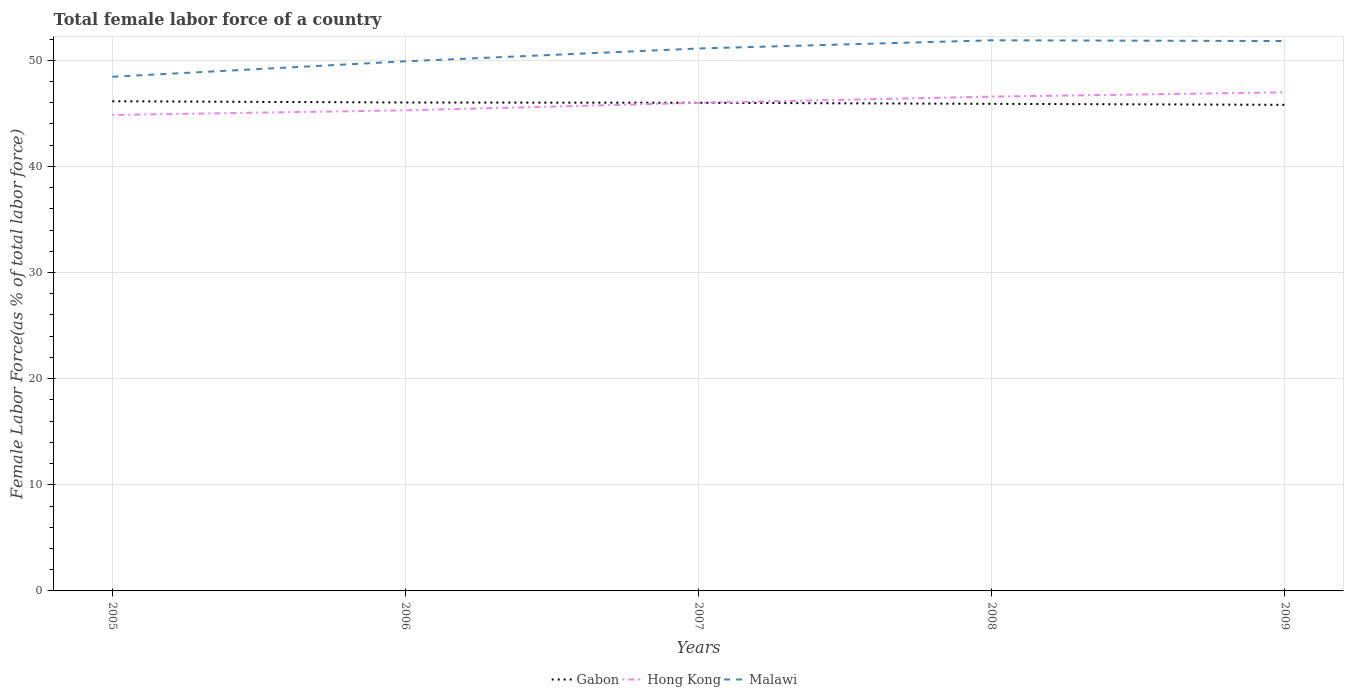Does the line corresponding to Gabon intersect with the line corresponding to Malawi?
Your answer should be very brief. No. Across all years, what is the maximum percentage of female labor force in Malawi?
Provide a short and direct response. 48.44. In which year was the percentage of female labor force in Hong Kong maximum?
Your answer should be very brief. 2005. What is the total percentage of female labor force in Malawi in the graph?
Keep it short and to the point. 0.07. What is the difference between the highest and the second highest percentage of female labor force in Gabon?
Your response must be concise. 0.34. What is the difference between the highest and the lowest percentage of female labor force in Gabon?
Your response must be concise. 3. Is the percentage of female labor force in Hong Kong strictly greater than the percentage of female labor force in Gabon over the years?
Give a very brief answer. No. How many lines are there?
Offer a very short reply. 3. Are the values on the major ticks of Y-axis written in scientific E-notation?
Make the answer very short. No. Does the graph contain any zero values?
Provide a succinct answer. No. Does the graph contain grids?
Provide a short and direct response. Yes. How are the legend labels stacked?
Your answer should be compact. Horizontal. What is the title of the graph?
Ensure brevity in your answer.  Total female labor force of a country. Does "Hungary" appear as one of the legend labels in the graph?
Ensure brevity in your answer.  No. What is the label or title of the Y-axis?
Ensure brevity in your answer.  Female Labor Force(as % of total labor force). What is the Female Labor Force(as % of total labor force) in Gabon in 2005?
Offer a terse response. 46.13. What is the Female Labor Force(as % of total labor force) in Hong Kong in 2005?
Provide a succinct answer. 44.84. What is the Female Labor Force(as % of total labor force) in Malawi in 2005?
Your response must be concise. 48.44. What is the Female Labor Force(as % of total labor force) in Gabon in 2006?
Offer a very short reply. 46.02. What is the Female Labor Force(as % of total labor force) of Hong Kong in 2006?
Keep it short and to the point. 45.28. What is the Female Labor Force(as % of total labor force) in Malawi in 2006?
Provide a succinct answer. 49.9. What is the Female Labor Force(as % of total labor force) of Gabon in 2007?
Keep it short and to the point. 45.99. What is the Female Labor Force(as % of total labor force) in Hong Kong in 2007?
Your response must be concise. 45.99. What is the Female Labor Force(as % of total labor force) in Malawi in 2007?
Offer a very short reply. 51.11. What is the Female Labor Force(as % of total labor force) of Gabon in 2008?
Offer a very short reply. 45.89. What is the Female Labor Force(as % of total labor force) in Hong Kong in 2008?
Ensure brevity in your answer.  46.57. What is the Female Labor Force(as % of total labor force) in Malawi in 2008?
Keep it short and to the point. 51.88. What is the Female Labor Force(as % of total labor force) in Gabon in 2009?
Your answer should be compact. 45.8. What is the Female Labor Force(as % of total labor force) in Hong Kong in 2009?
Offer a very short reply. 46.98. What is the Female Labor Force(as % of total labor force) of Malawi in 2009?
Keep it short and to the point. 51.81. Across all years, what is the maximum Female Labor Force(as % of total labor force) of Gabon?
Offer a very short reply. 46.13. Across all years, what is the maximum Female Labor Force(as % of total labor force) in Hong Kong?
Ensure brevity in your answer.  46.98. Across all years, what is the maximum Female Labor Force(as % of total labor force) of Malawi?
Your response must be concise. 51.88. Across all years, what is the minimum Female Labor Force(as % of total labor force) of Gabon?
Provide a short and direct response. 45.8. Across all years, what is the minimum Female Labor Force(as % of total labor force) in Hong Kong?
Provide a short and direct response. 44.84. Across all years, what is the minimum Female Labor Force(as % of total labor force) of Malawi?
Keep it short and to the point. 48.44. What is the total Female Labor Force(as % of total labor force) in Gabon in the graph?
Your response must be concise. 229.84. What is the total Female Labor Force(as % of total labor force) in Hong Kong in the graph?
Offer a very short reply. 229.65. What is the total Female Labor Force(as % of total labor force) of Malawi in the graph?
Ensure brevity in your answer.  253.13. What is the difference between the Female Labor Force(as % of total labor force) of Gabon in 2005 and that in 2006?
Offer a very short reply. 0.12. What is the difference between the Female Labor Force(as % of total labor force) in Hong Kong in 2005 and that in 2006?
Provide a succinct answer. -0.44. What is the difference between the Female Labor Force(as % of total labor force) of Malawi in 2005 and that in 2006?
Offer a terse response. -1.45. What is the difference between the Female Labor Force(as % of total labor force) of Gabon in 2005 and that in 2007?
Your answer should be very brief. 0.14. What is the difference between the Female Labor Force(as % of total labor force) of Hong Kong in 2005 and that in 2007?
Offer a very short reply. -1.14. What is the difference between the Female Labor Force(as % of total labor force) of Malawi in 2005 and that in 2007?
Offer a very short reply. -2.66. What is the difference between the Female Labor Force(as % of total labor force) in Gabon in 2005 and that in 2008?
Ensure brevity in your answer.  0.24. What is the difference between the Female Labor Force(as % of total labor force) of Hong Kong in 2005 and that in 2008?
Ensure brevity in your answer.  -1.73. What is the difference between the Female Labor Force(as % of total labor force) of Malawi in 2005 and that in 2008?
Make the answer very short. -3.43. What is the difference between the Female Labor Force(as % of total labor force) of Gabon in 2005 and that in 2009?
Your answer should be very brief. 0.34. What is the difference between the Female Labor Force(as % of total labor force) of Hong Kong in 2005 and that in 2009?
Your answer should be very brief. -2.13. What is the difference between the Female Labor Force(as % of total labor force) in Malawi in 2005 and that in 2009?
Ensure brevity in your answer.  -3.36. What is the difference between the Female Labor Force(as % of total labor force) in Gabon in 2006 and that in 2007?
Your response must be concise. 0.02. What is the difference between the Female Labor Force(as % of total labor force) in Hong Kong in 2006 and that in 2007?
Offer a very short reply. -0.71. What is the difference between the Female Labor Force(as % of total labor force) of Malawi in 2006 and that in 2007?
Your answer should be very brief. -1.21. What is the difference between the Female Labor Force(as % of total labor force) in Gabon in 2006 and that in 2008?
Ensure brevity in your answer.  0.13. What is the difference between the Female Labor Force(as % of total labor force) of Hong Kong in 2006 and that in 2008?
Make the answer very short. -1.29. What is the difference between the Female Labor Force(as % of total labor force) in Malawi in 2006 and that in 2008?
Make the answer very short. -1.98. What is the difference between the Female Labor Force(as % of total labor force) of Gabon in 2006 and that in 2009?
Provide a succinct answer. 0.22. What is the difference between the Female Labor Force(as % of total labor force) of Hong Kong in 2006 and that in 2009?
Your answer should be compact. -1.7. What is the difference between the Female Labor Force(as % of total labor force) of Malawi in 2006 and that in 2009?
Your answer should be very brief. -1.91. What is the difference between the Female Labor Force(as % of total labor force) of Gabon in 2007 and that in 2008?
Your answer should be compact. 0.1. What is the difference between the Female Labor Force(as % of total labor force) in Hong Kong in 2007 and that in 2008?
Keep it short and to the point. -0.58. What is the difference between the Female Labor Force(as % of total labor force) in Malawi in 2007 and that in 2008?
Your answer should be compact. -0.77. What is the difference between the Female Labor Force(as % of total labor force) of Gabon in 2007 and that in 2009?
Offer a terse response. 0.2. What is the difference between the Female Labor Force(as % of total labor force) in Hong Kong in 2007 and that in 2009?
Your answer should be very brief. -0.99. What is the difference between the Female Labor Force(as % of total labor force) of Malawi in 2007 and that in 2009?
Keep it short and to the point. -0.7. What is the difference between the Female Labor Force(as % of total labor force) of Gabon in 2008 and that in 2009?
Provide a short and direct response. 0.09. What is the difference between the Female Labor Force(as % of total labor force) of Hong Kong in 2008 and that in 2009?
Your answer should be compact. -0.41. What is the difference between the Female Labor Force(as % of total labor force) in Malawi in 2008 and that in 2009?
Keep it short and to the point. 0.07. What is the difference between the Female Labor Force(as % of total labor force) in Gabon in 2005 and the Female Labor Force(as % of total labor force) in Hong Kong in 2006?
Provide a succinct answer. 0.86. What is the difference between the Female Labor Force(as % of total labor force) in Gabon in 2005 and the Female Labor Force(as % of total labor force) in Malawi in 2006?
Keep it short and to the point. -3.76. What is the difference between the Female Labor Force(as % of total labor force) of Hong Kong in 2005 and the Female Labor Force(as % of total labor force) of Malawi in 2006?
Keep it short and to the point. -5.05. What is the difference between the Female Labor Force(as % of total labor force) of Gabon in 2005 and the Female Labor Force(as % of total labor force) of Hong Kong in 2007?
Your response must be concise. 0.15. What is the difference between the Female Labor Force(as % of total labor force) of Gabon in 2005 and the Female Labor Force(as % of total labor force) of Malawi in 2007?
Keep it short and to the point. -4.97. What is the difference between the Female Labor Force(as % of total labor force) in Hong Kong in 2005 and the Female Labor Force(as % of total labor force) in Malawi in 2007?
Your answer should be very brief. -6.26. What is the difference between the Female Labor Force(as % of total labor force) of Gabon in 2005 and the Female Labor Force(as % of total labor force) of Hong Kong in 2008?
Offer a very short reply. -0.43. What is the difference between the Female Labor Force(as % of total labor force) of Gabon in 2005 and the Female Labor Force(as % of total labor force) of Malawi in 2008?
Provide a succinct answer. -5.74. What is the difference between the Female Labor Force(as % of total labor force) in Hong Kong in 2005 and the Female Labor Force(as % of total labor force) in Malawi in 2008?
Make the answer very short. -7.03. What is the difference between the Female Labor Force(as % of total labor force) of Gabon in 2005 and the Female Labor Force(as % of total labor force) of Hong Kong in 2009?
Keep it short and to the point. -0.84. What is the difference between the Female Labor Force(as % of total labor force) in Gabon in 2005 and the Female Labor Force(as % of total labor force) in Malawi in 2009?
Your answer should be very brief. -5.67. What is the difference between the Female Labor Force(as % of total labor force) of Hong Kong in 2005 and the Female Labor Force(as % of total labor force) of Malawi in 2009?
Ensure brevity in your answer.  -6.96. What is the difference between the Female Labor Force(as % of total labor force) in Gabon in 2006 and the Female Labor Force(as % of total labor force) in Hong Kong in 2007?
Provide a short and direct response. 0.03. What is the difference between the Female Labor Force(as % of total labor force) in Gabon in 2006 and the Female Labor Force(as % of total labor force) in Malawi in 2007?
Keep it short and to the point. -5.09. What is the difference between the Female Labor Force(as % of total labor force) of Hong Kong in 2006 and the Female Labor Force(as % of total labor force) of Malawi in 2007?
Offer a terse response. -5.83. What is the difference between the Female Labor Force(as % of total labor force) in Gabon in 2006 and the Female Labor Force(as % of total labor force) in Hong Kong in 2008?
Provide a succinct answer. -0.55. What is the difference between the Female Labor Force(as % of total labor force) of Gabon in 2006 and the Female Labor Force(as % of total labor force) of Malawi in 2008?
Keep it short and to the point. -5.86. What is the difference between the Female Labor Force(as % of total labor force) in Hong Kong in 2006 and the Female Labor Force(as % of total labor force) in Malawi in 2008?
Keep it short and to the point. -6.6. What is the difference between the Female Labor Force(as % of total labor force) in Gabon in 2006 and the Female Labor Force(as % of total labor force) in Hong Kong in 2009?
Keep it short and to the point. -0.96. What is the difference between the Female Labor Force(as % of total labor force) in Gabon in 2006 and the Female Labor Force(as % of total labor force) in Malawi in 2009?
Your answer should be very brief. -5.79. What is the difference between the Female Labor Force(as % of total labor force) of Hong Kong in 2006 and the Female Labor Force(as % of total labor force) of Malawi in 2009?
Provide a short and direct response. -6.53. What is the difference between the Female Labor Force(as % of total labor force) in Gabon in 2007 and the Female Labor Force(as % of total labor force) in Hong Kong in 2008?
Give a very brief answer. -0.58. What is the difference between the Female Labor Force(as % of total labor force) in Gabon in 2007 and the Female Labor Force(as % of total labor force) in Malawi in 2008?
Ensure brevity in your answer.  -5.88. What is the difference between the Female Labor Force(as % of total labor force) in Hong Kong in 2007 and the Female Labor Force(as % of total labor force) in Malawi in 2008?
Keep it short and to the point. -5.89. What is the difference between the Female Labor Force(as % of total labor force) of Gabon in 2007 and the Female Labor Force(as % of total labor force) of Hong Kong in 2009?
Your response must be concise. -0.98. What is the difference between the Female Labor Force(as % of total labor force) of Gabon in 2007 and the Female Labor Force(as % of total labor force) of Malawi in 2009?
Offer a terse response. -5.81. What is the difference between the Female Labor Force(as % of total labor force) in Hong Kong in 2007 and the Female Labor Force(as % of total labor force) in Malawi in 2009?
Ensure brevity in your answer.  -5.82. What is the difference between the Female Labor Force(as % of total labor force) in Gabon in 2008 and the Female Labor Force(as % of total labor force) in Hong Kong in 2009?
Provide a succinct answer. -1.08. What is the difference between the Female Labor Force(as % of total labor force) in Gabon in 2008 and the Female Labor Force(as % of total labor force) in Malawi in 2009?
Make the answer very short. -5.92. What is the difference between the Female Labor Force(as % of total labor force) of Hong Kong in 2008 and the Female Labor Force(as % of total labor force) of Malawi in 2009?
Ensure brevity in your answer.  -5.24. What is the average Female Labor Force(as % of total labor force) of Gabon per year?
Keep it short and to the point. 45.97. What is the average Female Labor Force(as % of total labor force) in Hong Kong per year?
Provide a succinct answer. 45.93. What is the average Female Labor Force(as % of total labor force) of Malawi per year?
Make the answer very short. 50.63. In the year 2005, what is the difference between the Female Labor Force(as % of total labor force) of Gabon and Female Labor Force(as % of total labor force) of Hong Kong?
Your response must be concise. 1.29. In the year 2005, what is the difference between the Female Labor Force(as % of total labor force) of Gabon and Female Labor Force(as % of total labor force) of Malawi?
Give a very brief answer. -2.31. In the year 2005, what is the difference between the Female Labor Force(as % of total labor force) in Hong Kong and Female Labor Force(as % of total labor force) in Malawi?
Ensure brevity in your answer.  -3.6. In the year 2006, what is the difference between the Female Labor Force(as % of total labor force) in Gabon and Female Labor Force(as % of total labor force) in Hong Kong?
Provide a succinct answer. 0.74. In the year 2006, what is the difference between the Female Labor Force(as % of total labor force) in Gabon and Female Labor Force(as % of total labor force) in Malawi?
Provide a short and direct response. -3.88. In the year 2006, what is the difference between the Female Labor Force(as % of total labor force) in Hong Kong and Female Labor Force(as % of total labor force) in Malawi?
Make the answer very short. -4.62. In the year 2007, what is the difference between the Female Labor Force(as % of total labor force) of Gabon and Female Labor Force(as % of total labor force) of Hong Kong?
Provide a succinct answer. 0.01. In the year 2007, what is the difference between the Female Labor Force(as % of total labor force) of Gabon and Female Labor Force(as % of total labor force) of Malawi?
Your response must be concise. -5.11. In the year 2007, what is the difference between the Female Labor Force(as % of total labor force) of Hong Kong and Female Labor Force(as % of total labor force) of Malawi?
Ensure brevity in your answer.  -5.12. In the year 2008, what is the difference between the Female Labor Force(as % of total labor force) in Gabon and Female Labor Force(as % of total labor force) in Hong Kong?
Your answer should be compact. -0.68. In the year 2008, what is the difference between the Female Labor Force(as % of total labor force) in Gabon and Female Labor Force(as % of total labor force) in Malawi?
Your answer should be very brief. -5.99. In the year 2008, what is the difference between the Female Labor Force(as % of total labor force) in Hong Kong and Female Labor Force(as % of total labor force) in Malawi?
Offer a very short reply. -5.31. In the year 2009, what is the difference between the Female Labor Force(as % of total labor force) of Gabon and Female Labor Force(as % of total labor force) of Hong Kong?
Your answer should be compact. -1.18. In the year 2009, what is the difference between the Female Labor Force(as % of total labor force) of Gabon and Female Labor Force(as % of total labor force) of Malawi?
Your answer should be compact. -6.01. In the year 2009, what is the difference between the Female Labor Force(as % of total labor force) in Hong Kong and Female Labor Force(as % of total labor force) in Malawi?
Keep it short and to the point. -4.83. What is the ratio of the Female Labor Force(as % of total labor force) of Hong Kong in 2005 to that in 2006?
Your response must be concise. 0.99. What is the ratio of the Female Labor Force(as % of total labor force) of Malawi in 2005 to that in 2006?
Provide a succinct answer. 0.97. What is the ratio of the Female Labor Force(as % of total labor force) in Hong Kong in 2005 to that in 2007?
Make the answer very short. 0.98. What is the ratio of the Female Labor Force(as % of total labor force) of Malawi in 2005 to that in 2007?
Offer a very short reply. 0.95. What is the ratio of the Female Labor Force(as % of total labor force) of Hong Kong in 2005 to that in 2008?
Ensure brevity in your answer.  0.96. What is the ratio of the Female Labor Force(as % of total labor force) in Malawi in 2005 to that in 2008?
Give a very brief answer. 0.93. What is the ratio of the Female Labor Force(as % of total labor force) of Gabon in 2005 to that in 2009?
Ensure brevity in your answer.  1.01. What is the ratio of the Female Labor Force(as % of total labor force) of Hong Kong in 2005 to that in 2009?
Ensure brevity in your answer.  0.95. What is the ratio of the Female Labor Force(as % of total labor force) in Malawi in 2005 to that in 2009?
Offer a terse response. 0.94. What is the ratio of the Female Labor Force(as % of total labor force) of Hong Kong in 2006 to that in 2007?
Your answer should be very brief. 0.98. What is the ratio of the Female Labor Force(as % of total labor force) of Malawi in 2006 to that in 2007?
Keep it short and to the point. 0.98. What is the ratio of the Female Labor Force(as % of total labor force) in Gabon in 2006 to that in 2008?
Your response must be concise. 1. What is the ratio of the Female Labor Force(as % of total labor force) of Hong Kong in 2006 to that in 2008?
Keep it short and to the point. 0.97. What is the ratio of the Female Labor Force(as % of total labor force) of Malawi in 2006 to that in 2008?
Your answer should be compact. 0.96. What is the ratio of the Female Labor Force(as % of total labor force) of Hong Kong in 2006 to that in 2009?
Offer a very short reply. 0.96. What is the ratio of the Female Labor Force(as % of total labor force) of Malawi in 2006 to that in 2009?
Your answer should be compact. 0.96. What is the ratio of the Female Labor Force(as % of total labor force) in Gabon in 2007 to that in 2008?
Keep it short and to the point. 1. What is the ratio of the Female Labor Force(as % of total labor force) of Hong Kong in 2007 to that in 2008?
Your answer should be compact. 0.99. What is the ratio of the Female Labor Force(as % of total labor force) in Malawi in 2007 to that in 2008?
Your answer should be compact. 0.99. What is the ratio of the Female Labor Force(as % of total labor force) in Gabon in 2007 to that in 2009?
Your answer should be compact. 1. What is the ratio of the Female Labor Force(as % of total labor force) of Hong Kong in 2007 to that in 2009?
Offer a terse response. 0.98. What is the ratio of the Female Labor Force(as % of total labor force) of Malawi in 2007 to that in 2009?
Your answer should be very brief. 0.99. What is the difference between the highest and the second highest Female Labor Force(as % of total labor force) in Gabon?
Ensure brevity in your answer.  0.12. What is the difference between the highest and the second highest Female Labor Force(as % of total labor force) in Hong Kong?
Give a very brief answer. 0.41. What is the difference between the highest and the second highest Female Labor Force(as % of total labor force) in Malawi?
Offer a very short reply. 0.07. What is the difference between the highest and the lowest Female Labor Force(as % of total labor force) in Gabon?
Provide a succinct answer. 0.34. What is the difference between the highest and the lowest Female Labor Force(as % of total labor force) of Hong Kong?
Offer a very short reply. 2.13. What is the difference between the highest and the lowest Female Labor Force(as % of total labor force) of Malawi?
Offer a very short reply. 3.43. 